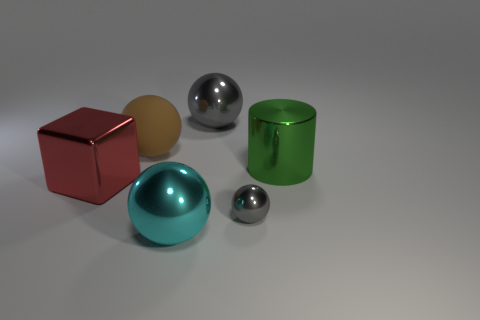Subtract all large gray metal balls. How many balls are left? 3 Subtract all cyan balls. How many balls are left? 3 Subtract all cylinders. How many objects are left? 5 Subtract 1 spheres. How many spheres are left? 3 Add 3 big shiny objects. How many objects exist? 9 Subtract 1 cyan balls. How many objects are left? 5 Subtract all brown spheres. Subtract all green blocks. How many spheres are left? 3 Subtract all gray spheres. How many yellow cubes are left? 0 Subtract all small cyan shiny cubes. Subtract all big spheres. How many objects are left? 3 Add 3 big red metal things. How many big red metal things are left? 4 